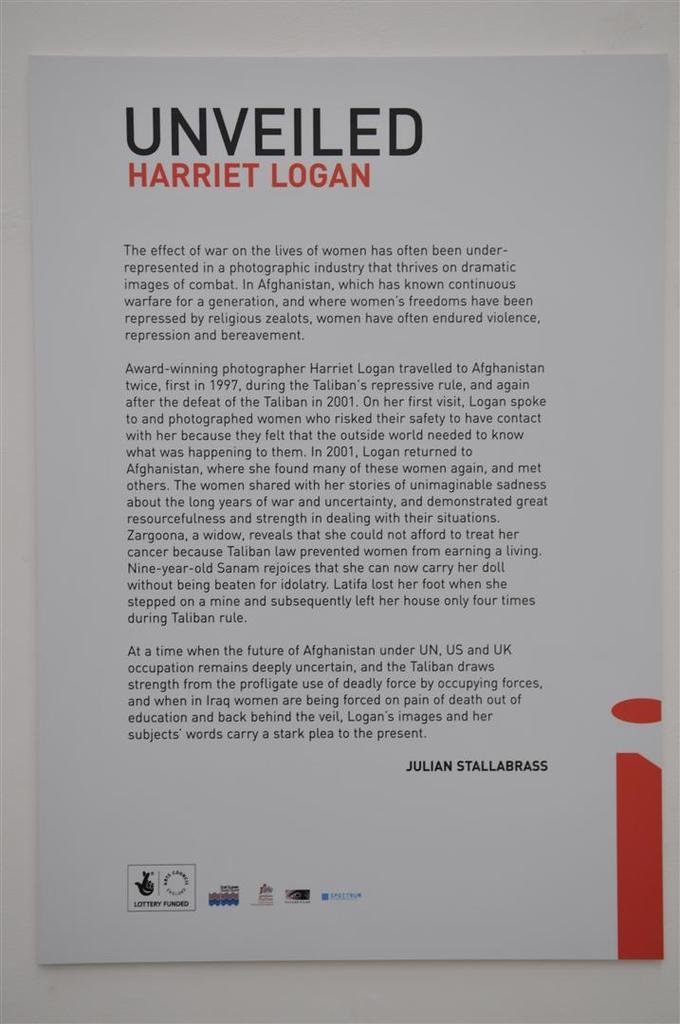<image>
Give a short and clear explanation of the subsequent image. A small poster that says Unveiled Harriet Logan on it. 